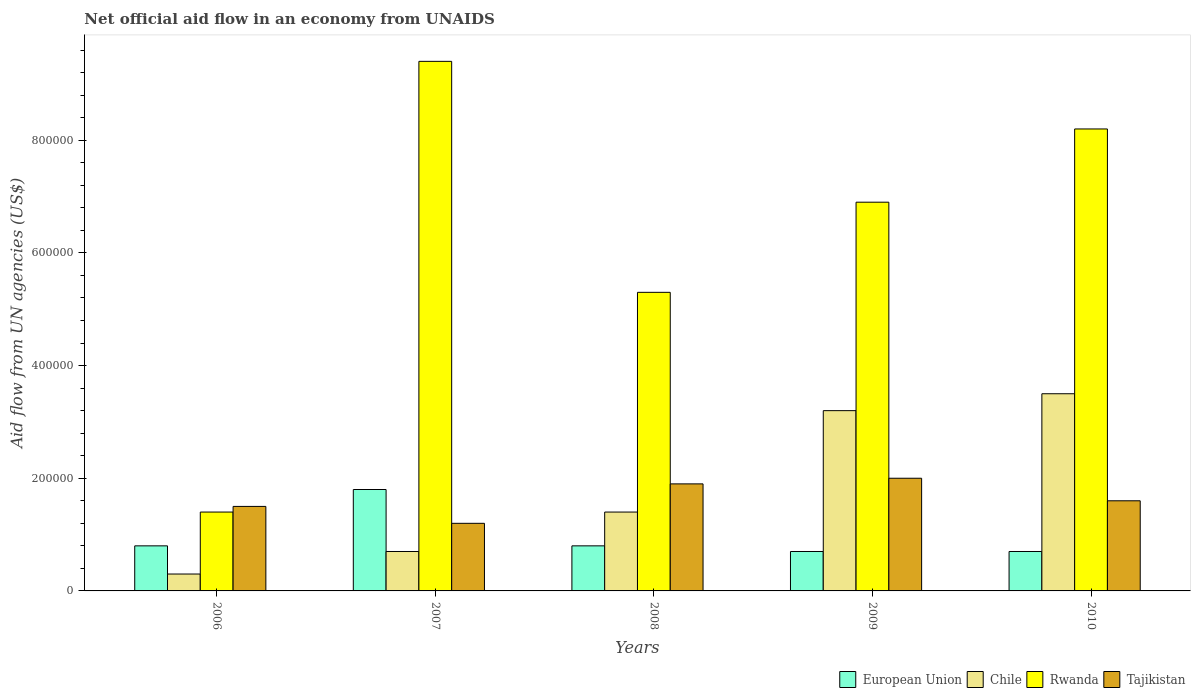How many different coloured bars are there?
Your answer should be very brief. 4. How many bars are there on the 3rd tick from the left?
Your answer should be compact. 4. How many bars are there on the 4th tick from the right?
Provide a short and direct response. 4. What is the label of the 4th group of bars from the left?
Offer a terse response. 2009. What is the net official aid flow in Rwanda in 2010?
Your response must be concise. 8.20e+05. Across all years, what is the maximum net official aid flow in Tajikistan?
Your response must be concise. 2.00e+05. Across all years, what is the minimum net official aid flow in Chile?
Ensure brevity in your answer.  3.00e+04. In which year was the net official aid flow in Tajikistan maximum?
Provide a short and direct response. 2009. In which year was the net official aid flow in Tajikistan minimum?
Your answer should be compact. 2007. What is the total net official aid flow in Tajikistan in the graph?
Your answer should be compact. 8.20e+05. What is the difference between the net official aid flow in Tajikistan in 2006 and that in 2009?
Offer a very short reply. -5.00e+04. What is the average net official aid flow in Tajikistan per year?
Your answer should be very brief. 1.64e+05. In the year 2006, what is the difference between the net official aid flow in Tajikistan and net official aid flow in Chile?
Keep it short and to the point. 1.20e+05. In how many years, is the net official aid flow in Chile greater than 40000 US$?
Provide a succinct answer. 4. What is the ratio of the net official aid flow in Rwanda in 2006 to that in 2010?
Your response must be concise. 0.17. Is the net official aid flow in Chile in 2007 less than that in 2010?
Your answer should be compact. Yes. Is the difference between the net official aid flow in Tajikistan in 2009 and 2010 greater than the difference between the net official aid flow in Chile in 2009 and 2010?
Your answer should be compact. Yes. What is the difference between the highest and the second highest net official aid flow in Chile?
Your answer should be very brief. 3.00e+04. What is the difference between the highest and the lowest net official aid flow in Chile?
Your response must be concise. 3.20e+05. In how many years, is the net official aid flow in Rwanda greater than the average net official aid flow in Rwanda taken over all years?
Your response must be concise. 3. What does the 2nd bar from the left in 2010 represents?
Provide a succinct answer. Chile. What does the 3rd bar from the right in 2009 represents?
Offer a very short reply. Chile. Are all the bars in the graph horizontal?
Offer a very short reply. No. What is the difference between two consecutive major ticks on the Y-axis?
Your response must be concise. 2.00e+05. Are the values on the major ticks of Y-axis written in scientific E-notation?
Your answer should be very brief. No. Does the graph contain any zero values?
Offer a very short reply. No. Does the graph contain grids?
Ensure brevity in your answer.  No. What is the title of the graph?
Your response must be concise. Net official aid flow in an economy from UNAIDS. Does "Romania" appear as one of the legend labels in the graph?
Provide a succinct answer. No. What is the label or title of the Y-axis?
Your response must be concise. Aid flow from UN agencies (US$). What is the Aid flow from UN agencies (US$) of Tajikistan in 2006?
Offer a very short reply. 1.50e+05. What is the Aid flow from UN agencies (US$) of Chile in 2007?
Provide a succinct answer. 7.00e+04. What is the Aid flow from UN agencies (US$) of Rwanda in 2007?
Ensure brevity in your answer.  9.40e+05. What is the Aid flow from UN agencies (US$) of European Union in 2008?
Provide a short and direct response. 8.00e+04. What is the Aid flow from UN agencies (US$) of Chile in 2008?
Your answer should be very brief. 1.40e+05. What is the Aid flow from UN agencies (US$) of Rwanda in 2008?
Offer a very short reply. 5.30e+05. What is the Aid flow from UN agencies (US$) of Tajikistan in 2008?
Keep it short and to the point. 1.90e+05. What is the Aid flow from UN agencies (US$) in European Union in 2009?
Make the answer very short. 7.00e+04. What is the Aid flow from UN agencies (US$) in Rwanda in 2009?
Provide a short and direct response. 6.90e+05. What is the Aid flow from UN agencies (US$) in Tajikistan in 2009?
Offer a very short reply. 2.00e+05. What is the Aid flow from UN agencies (US$) in European Union in 2010?
Offer a very short reply. 7.00e+04. What is the Aid flow from UN agencies (US$) in Chile in 2010?
Offer a terse response. 3.50e+05. What is the Aid flow from UN agencies (US$) in Rwanda in 2010?
Offer a terse response. 8.20e+05. What is the Aid flow from UN agencies (US$) of Tajikistan in 2010?
Keep it short and to the point. 1.60e+05. Across all years, what is the maximum Aid flow from UN agencies (US$) in Rwanda?
Make the answer very short. 9.40e+05. Across all years, what is the maximum Aid flow from UN agencies (US$) in Tajikistan?
Give a very brief answer. 2.00e+05. Across all years, what is the minimum Aid flow from UN agencies (US$) of European Union?
Give a very brief answer. 7.00e+04. Across all years, what is the minimum Aid flow from UN agencies (US$) in Rwanda?
Provide a succinct answer. 1.40e+05. What is the total Aid flow from UN agencies (US$) in Chile in the graph?
Provide a short and direct response. 9.10e+05. What is the total Aid flow from UN agencies (US$) of Rwanda in the graph?
Ensure brevity in your answer.  3.12e+06. What is the total Aid flow from UN agencies (US$) in Tajikistan in the graph?
Keep it short and to the point. 8.20e+05. What is the difference between the Aid flow from UN agencies (US$) in Chile in 2006 and that in 2007?
Offer a very short reply. -4.00e+04. What is the difference between the Aid flow from UN agencies (US$) of Rwanda in 2006 and that in 2007?
Make the answer very short. -8.00e+05. What is the difference between the Aid flow from UN agencies (US$) in European Union in 2006 and that in 2008?
Provide a short and direct response. 0. What is the difference between the Aid flow from UN agencies (US$) in Rwanda in 2006 and that in 2008?
Your answer should be very brief. -3.90e+05. What is the difference between the Aid flow from UN agencies (US$) in Tajikistan in 2006 and that in 2008?
Provide a short and direct response. -4.00e+04. What is the difference between the Aid flow from UN agencies (US$) of European Union in 2006 and that in 2009?
Offer a very short reply. 10000. What is the difference between the Aid flow from UN agencies (US$) of Rwanda in 2006 and that in 2009?
Offer a terse response. -5.50e+05. What is the difference between the Aid flow from UN agencies (US$) of European Union in 2006 and that in 2010?
Ensure brevity in your answer.  10000. What is the difference between the Aid flow from UN agencies (US$) in Chile in 2006 and that in 2010?
Make the answer very short. -3.20e+05. What is the difference between the Aid flow from UN agencies (US$) of Rwanda in 2006 and that in 2010?
Offer a terse response. -6.80e+05. What is the difference between the Aid flow from UN agencies (US$) in European Union in 2007 and that in 2008?
Provide a short and direct response. 1.00e+05. What is the difference between the Aid flow from UN agencies (US$) of Chile in 2007 and that in 2008?
Offer a terse response. -7.00e+04. What is the difference between the Aid flow from UN agencies (US$) of Rwanda in 2007 and that in 2008?
Keep it short and to the point. 4.10e+05. What is the difference between the Aid flow from UN agencies (US$) in Chile in 2007 and that in 2010?
Keep it short and to the point. -2.80e+05. What is the difference between the Aid flow from UN agencies (US$) of Rwanda in 2007 and that in 2010?
Provide a short and direct response. 1.20e+05. What is the difference between the Aid flow from UN agencies (US$) in Rwanda in 2008 and that in 2009?
Offer a very short reply. -1.60e+05. What is the difference between the Aid flow from UN agencies (US$) of Tajikistan in 2008 and that in 2009?
Keep it short and to the point. -10000. What is the difference between the Aid flow from UN agencies (US$) of European Union in 2008 and that in 2010?
Your answer should be compact. 10000. What is the difference between the Aid flow from UN agencies (US$) of European Union in 2009 and that in 2010?
Offer a very short reply. 0. What is the difference between the Aid flow from UN agencies (US$) of Tajikistan in 2009 and that in 2010?
Provide a short and direct response. 4.00e+04. What is the difference between the Aid flow from UN agencies (US$) of European Union in 2006 and the Aid flow from UN agencies (US$) of Rwanda in 2007?
Your response must be concise. -8.60e+05. What is the difference between the Aid flow from UN agencies (US$) in European Union in 2006 and the Aid flow from UN agencies (US$) in Tajikistan in 2007?
Offer a very short reply. -4.00e+04. What is the difference between the Aid flow from UN agencies (US$) in Chile in 2006 and the Aid flow from UN agencies (US$) in Rwanda in 2007?
Your response must be concise. -9.10e+05. What is the difference between the Aid flow from UN agencies (US$) of Chile in 2006 and the Aid flow from UN agencies (US$) of Tajikistan in 2007?
Give a very brief answer. -9.00e+04. What is the difference between the Aid flow from UN agencies (US$) in European Union in 2006 and the Aid flow from UN agencies (US$) in Rwanda in 2008?
Your response must be concise. -4.50e+05. What is the difference between the Aid flow from UN agencies (US$) of Chile in 2006 and the Aid flow from UN agencies (US$) of Rwanda in 2008?
Your answer should be very brief. -5.00e+05. What is the difference between the Aid flow from UN agencies (US$) in Chile in 2006 and the Aid flow from UN agencies (US$) in Tajikistan in 2008?
Your answer should be very brief. -1.60e+05. What is the difference between the Aid flow from UN agencies (US$) in European Union in 2006 and the Aid flow from UN agencies (US$) in Rwanda in 2009?
Provide a succinct answer. -6.10e+05. What is the difference between the Aid flow from UN agencies (US$) of European Union in 2006 and the Aid flow from UN agencies (US$) of Tajikistan in 2009?
Your response must be concise. -1.20e+05. What is the difference between the Aid flow from UN agencies (US$) in Chile in 2006 and the Aid flow from UN agencies (US$) in Rwanda in 2009?
Your answer should be very brief. -6.60e+05. What is the difference between the Aid flow from UN agencies (US$) of European Union in 2006 and the Aid flow from UN agencies (US$) of Chile in 2010?
Offer a very short reply. -2.70e+05. What is the difference between the Aid flow from UN agencies (US$) in European Union in 2006 and the Aid flow from UN agencies (US$) in Rwanda in 2010?
Offer a very short reply. -7.40e+05. What is the difference between the Aid flow from UN agencies (US$) in Chile in 2006 and the Aid flow from UN agencies (US$) in Rwanda in 2010?
Provide a succinct answer. -7.90e+05. What is the difference between the Aid flow from UN agencies (US$) in Chile in 2006 and the Aid flow from UN agencies (US$) in Tajikistan in 2010?
Provide a succinct answer. -1.30e+05. What is the difference between the Aid flow from UN agencies (US$) of Rwanda in 2006 and the Aid flow from UN agencies (US$) of Tajikistan in 2010?
Ensure brevity in your answer.  -2.00e+04. What is the difference between the Aid flow from UN agencies (US$) in European Union in 2007 and the Aid flow from UN agencies (US$) in Chile in 2008?
Make the answer very short. 4.00e+04. What is the difference between the Aid flow from UN agencies (US$) of European Union in 2007 and the Aid flow from UN agencies (US$) of Rwanda in 2008?
Keep it short and to the point. -3.50e+05. What is the difference between the Aid flow from UN agencies (US$) in Chile in 2007 and the Aid flow from UN agencies (US$) in Rwanda in 2008?
Give a very brief answer. -4.60e+05. What is the difference between the Aid flow from UN agencies (US$) in Chile in 2007 and the Aid flow from UN agencies (US$) in Tajikistan in 2008?
Provide a short and direct response. -1.20e+05. What is the difference between the Aid flow from UN agencies (US$) in Rwanda in 2007 and the Aid flow from UN agencies (US$) in Tajikistan in 2008?
Your answer should be very brief. 7.50e+05. What is the difference between the Aid flow from UN agencies (US$) in European Union in 2007 and the Aid flow from UN agencies (US$) in Chile in 2009?
Keep it short and to the point. -1.40e+05. What is the difference between the Aid flow from UN agencies (US$) in European Union in 2007 and the Aid flow from UN agencies (US$) in Rwanda in 2009?
Offer a terse response. -5.10e+05. What is the difference between the Aid flow from UN agencies (US$) in European Union in 2007 and the Aid flow from UN agencies (US$) in Tajikistan in 2009?
Offer a very short reply. -2.00e+04. What is the difference between the Aid flow from UN agencies (US$) in Chile in 2007 and the Aid flow from UN agencies (US$) in Rwanda in 2009?
Your response must be concise. -6.20e+05. What is the difference between the Aid flow from UN agencies (US$) of Rwanda in 2007 and the Aid flow from UN agencies (US$) of Tajikistan in 2009?
Give a very brief answer. 7.40e+05. What is the difference between the Aid flow from UN agencies (US$) in European Union in 2007 and the Aid flow from UN agencies (US$) in Chile in 2010?
Make the answer very short. -1.70e+05. What is the difference between the Aid flow from UN agencies (US$) of European Union in 2007 and the Aid flow from UN agencies (US$) of Rwanda in 2010?
Provide a short and direct response. -6.40e+05. What is the difference between the Aid flow from UN agencies (US$) in European Union in 2007 and the Aid flow from UN agencies (US$) in Tajikistan in 2010?
Give a very brief answer. 2.00e+04. What is the difference between the Aid flow from UN agencies (US$) in Chile in 2007 and the Aid flow from UN agencies (US$) in Rwanda in 2010?
Provide a short and direct response. -7.50e+05. What is the difference between the Aid flow from UN agencies (US$) in Rwanda in 2007 and the Aid flow from UN agencies (US$) in Tajikistan in 2010?
Make the answer very short. 7.80e+05. What is the difference between the Aid flow from UN agencies (US$) in European Union in 2008 and the Aid flow from UN agencies (US$) in Chile in 2009?
Keep it short and to the point. -2.40e+05. What is the difference between the Aid flow from UN agencies (US$) of European Union in 2008 and the Aid flow from UN agencies (US$) of Rwanda in 2009?
Offer a terse response. -6.10e+05. What is the difference between the Aid flow from UN agencies (US$) in European Union in 2008 and the Aid flow from UN agencies (US$) in Tajikistan in 2009?
Make the answer very short. -1.20e+05. What is the difference between the Aid flow from UN agencies (US$) in Chile in 2008 and the Aid flow from UN agencies (US$) in Rwanda in 2009?
Provide a succinct answer. -5.50e+05. What is the difference between the Aid flow from UN agencies (US$) in Chile in 2008 and the Aid flow from UN agencies (US$) in Tajikistan in 2009?
Provide a succinct answer. -6.00e+04. What is the difference between the Aid flow from UN agencies (US$) of European Union in 2008 and the Aid flow from UN agencies (US$) of Chile in 2010?
Provide a short and direct response. -2.70e+05. What is the difference between the Aid flow from UN agencies (US$) in European Union in 2008 and the Aid flow from UN agencies (US$) in Rwanda in 2010?
Keep it short and to the point. -7.40e+05. What is the difference between the Aid flow from UN agencies (US$) of Chile in 2008 and the Aid flow from UN agencies (US$) of Rwanda in 2010?
Offer a very short reply. -6.80e+05. What is the difference between the Aid flow from UN agencies (US$) in Chile in 2008 and the Aid flow from UN agencies (US$) in Tajikistan in 2010?
Give a very brief answer. -2.00e+04. What is the difference between the Aid flow from UN agencies (US$) of European Union in 2009 and the Aid flow from UN agencies (US$) of Chile in 2010?
Keep it short and to the point. -2.80e+05. What is the difference between the Aid flow from UN agencies (US$) in European Union in 2009 and the Aid flow from UN agencies (US$) in Rwanda in 2010?
Offer a terse response. -7.50e+05. What is the difference between the Aid flow from UN agencies (US$) of Chile in 2009 and the Aid flow from UN agencies (US$) of Rwanda in 2010?
Keep it short and to the point. -5.00e+05. What is the difference between the Aid flow from UN agencies (US$) of Rwanda in 2009 and the Aid flow from UN agencies (US$) of Tajikistan in 2010?
Keep it short and to the point. 5.30e+05. What is the average Aid flow from UN agencies (US$) of European Union per year?
Offer a very short reply. 9.60e+04. What is the average Aid flow from UN agencies (US$) in Chile per year?
Offer a terse response. 1.82e+05. What is the average Aid flow from UN agencies (US$) of Rwanda per year?
Give a very brief answer. 6.24e+05. What is the average Aid flow from UN agencies (US$) in Tajikistan per year?
Provide a short and direct response. 1.64e+05. In the year 2006, what is the difference between the Aid flow from UN agencies (US$) of European Union and Aid flow from UN agencies (US$) of Rwanda?
Make the answer very short. -6.00e+04. In the year 2006, what is the difference between the Aid flow from UN agencies (US$) of Rwanda and Aid flow from UN agencies (US$) of Tajikistan?
Provide a short and direct response. -10000. In the year 2007, what is the difference between the Aid flow from UN agencies (US$) of European Union and Aid flow from UN agencies (US$) of Rwanda?
Provide a succinct answer. -7.60e+05. In the year 2007, what is the difference between the Aid flow from UN agencies (US$) in Chile and Aid flow from UN agencies (US$) in Rwanda?
Make the answer very short. -8.70e+05. In the year 2007, what is the difference between the Aid flow from UN agencies (US$) in Chile and Aid flow from UN agencies (US$) in Tajikistan?
Make the answer very short. -5.00e+04. In the year 2007, what is the difference between the Aid flow from UN agencies (US$) of Rwanda and Aid flow from UN agencies (US$) of Tajikistan?
Make the answer very short. 8.20e+05. In the year 2008, what is the difference between the Aid flow from UN agencies (US$) of European Union and Aid flow from UN agencies (US$) of Rwanda?
Offer a very short reply. -4.50e+05. In the year 2008, what is the difference between the Aid flow from UN agencies (US$) in European Union and Aid flow from UN agencies (US$) in Tajikistan?
Provide a succinct answer. -1.10e+05. In the year 2008, what is the difference between the Aid flow from UN agencies (US$) in Chile and Aid flow from UN agencies (US$) in Rwanda?
Offer a very short reply. -3.90e+05. In the year 2009, what is the difference between the Aid flow from UN agencies (US$) of European Union and Aid flow from UN agencies (US$) of Rwanda?
Make the answer very short. -6.20e+05. In the year 2009, what is the difference between the Aid flow from UN agencies (US$) of European Union and Aid flow from UN agencies (US$) of Tajikistan?
Provide a short and direct response. -1.30e+05. In the year 2009, what is the difference between the Aid flow from UN agencies (US$) in Chile and Aid flow from UN agencies (US$) in Rwanda?
Ensure brevity in your answer.  -3.70e+05. In the year 2009, what is the difference between the Aid flow from UN agencies (US$) of Chile and Aid flow from UN agencies (US$) of Tajikistan?
Offer a terse response. 1.20e+05. In the year 2010, what is the difference between the Aid flow from UN agencies (US$) of European Union and Aid flow from UN agencies (US$) of Chile?
Your response must be concise. -2.80e+05. In the year 2010, what is the difference between the Aid flow from UN agencies (US$) in European Union and Aid flow from UN agencies (US$) in Rwanda?
Ensure brevity in your answer.  -7.50e+05. In the year 2010, what is the difference between the Aid flow from UN agencies (US$) of Chile and Aid flow from UN agencies (US$) of Rwanda?
Ensure brevity in your answer.  -4.70e+05. What is the ratio of the Aid flow from UN agencies (US$) of European Union in 2006 to that in 2007?
Offer a very short reply. 0.44. What is the ratio of the Aid flow from UN agencies (US$) in Chile in 2006 to that in 2007?
Ensure brevity in your answer.  0.43. What is the ratio of the Aid flow from UN agencies (US$) of Rwanda in 2006 to that in 2007?
Your answer should be very brief. 0.15. What is the ratio of the Aid flow from UN agencies (US$) of European Union in 2006 to that in 2008?
Provide a succinct answer. 1. What is the ratio of the Aid flow from UN agencies (US$) in Chile in 2006 to that in 2008?
Make the answer very short. 0.21. What is the ratio of the Aid flow from UN agencies (US$) in Rwanda in 2006 to that in 2008?
Make the answer very short. 0.26. What is the ratio of the Aid flow from UN agencies (US$) in Tajikistan in 2006 to that in 2008?
Offer a terse response. 0.79. What is the ratio of the Aid flow from UN agencies (US$) in Chile in 2006 to that in 2009?
Keep it short and to the point. 0.09. What is the ratio of the Aid flow from UN agencies (US$) in Rwanda in 2006 to that in 2009?
Provide a succinct answer. 0.2. What is the ratio of the Aid flow from UN agencies (US$) of Chile in 2006 to that in 2010?
Your answer should be compact. 0.09. What is the ratio of the Aid flow from UN agencies (US$) of Rwanda in 2006 to that in 2010?
Offer a terse response. 0.17. What is the ratio of the Aid flow from UN agencies (US$) in European Union in 2007 to that in 2008?
Your response must be concise. 2.25. What is the ratio of the Aid flow from UN agencies (US$) in Rwanda in 2007 to that in 2008?
Your response must be concise. 1.77. What is the ratio of the Aid flow from UN agencies (US$) of Tajikistan in 2007 to that in 2008?
Give a very brief answer. 0.63. What is the ratio of the Aid flow from UN agencies (US$) of European Union in 2007 to that in 2009?
Your response must be concise. 2.57. What is the ratio of the Aid flow from UN agencies (US$) in Chile in 2007 to that in 2009?
Keep it short and to the point. 0.22. What is the ratio of the Aid flow from UN agencies (US$) of Rwanda in 2007 to that in 2009?
Give a very brief answer. 1.36. What is the ratio of the Aid flow from UN agencies (US$) in Tajikistan in 2007 to that in 2009?
Offer a very short reply. 0.6. What is the ratio of the Aid flow from UN agencies (US$) in European Union in 2007 to that in 2010?
Provide a short and direct response. 2.57. What is the ratio of the Aid flow from UN agencies (US$) in Chile in 2007 to that in 2010?
Your answer should be very brief. 0.2. What is the ratio of the Aid flow from UN agencies (US$) in Rwanda in 2007 to that in 2010?
Offer a terse response. 1.15. What is the ratio of the Aid flow from UN agencies (US$) of Chile in 2008 to that in 2009?
Provide a short and direct response. 0.44. What is the ratio of the Aid flow from UN agencies (US$) of Rwanda in 2008 to that in 2009?
Keep it short and to the point. 0.77. What is the ratio of the Aid flow from UN agencies (US$) of Tajikistan in 2008 to that in 2009?
Offer a very short reply. 0.95. What is the ratio of the Aid flow from UN agencies (US$) in Rwanda in 2008 to that in 2010?
Provide a short and direct response. 0.65. What is the ratio of the Aid flow from UN agencies (US$) in Tajikistan in 2008 to that in 2010?
Provide a short and direct response. 1.19. What is the ratio of the Aid flow from UN agencies (US$) of Chile in 2009 to that in 2010?
Give a very brief answer. 0.91. What is the ratio of the Aid flow from UN agencies (US$) of Rwanda in 2009 to that in 2010?
Provide a succinct answer. 0.84. What is the ratio of the Aid flow from UN agencies (US$) in Tajikistan in 2009 to that in 2010?
Make the answer very short. 1.25. What is the difference between the highest and the second highest Aid flow from UN agencies (US$) of European Union?
Ensure brevity in your answer.  1.00e+05. What is the difference between the highest and the lowest Aid flow from UN agencies (US$) in Chile?
Provide a short and direct response. 3.20e+05. 